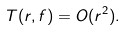Convert formula to latex. <formula><loc_0><loc_0><loc_500><loc_500>T ( r , f ) = O ( r ^ { 2 } ) .</formula> 